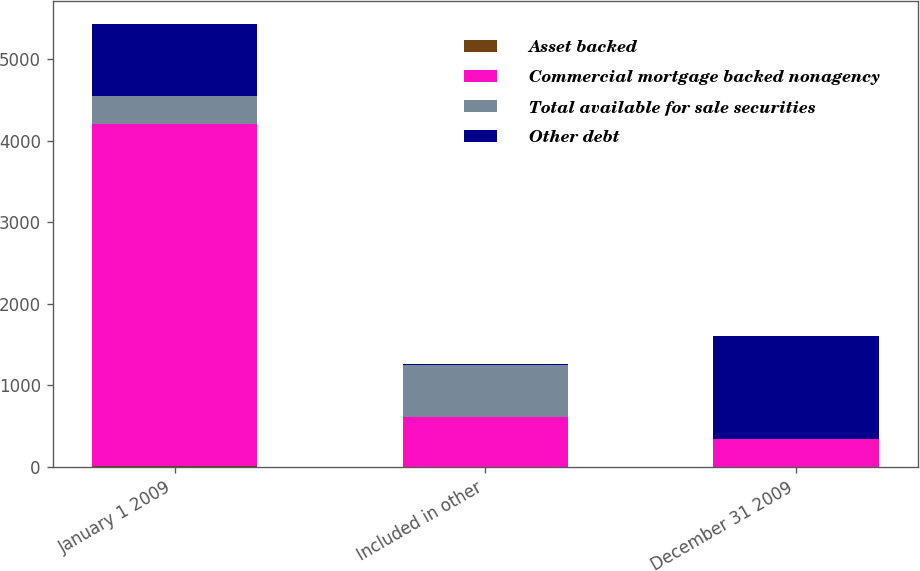<chart> <loc_0><loc_0><loc_500><loc_500><stacked_bar_chart><ecel><fcel>January 1 2009<fcel>Included in other<fcel>December 31 2009<nl><fcel>Asset backed<fcel>7<fcel>2<fcel>5<nl><fcel>Commercial mortgage backed nonagency<fcel>4203<fcel>616<fcel>337<nl><fcel>Total available for sale securities<fcel>337<fcel>627<fcel>6<nl><fcel>Other debt<fcel>892<fcel>22<fcel>1254<nl></chart> 